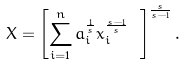Convert formula to latex. <formula><loc_0><loc_0><loc_500><loc_500>X = \left [ \sum _ { i = 1 } ^ { n } a _ { i } ^ { \frac { 1 } { s } } x _ { i } ^ { \frac { s - 1 } { s } } \ \right ] ^ { \frac { s } { s - 1 } } .</formula> 